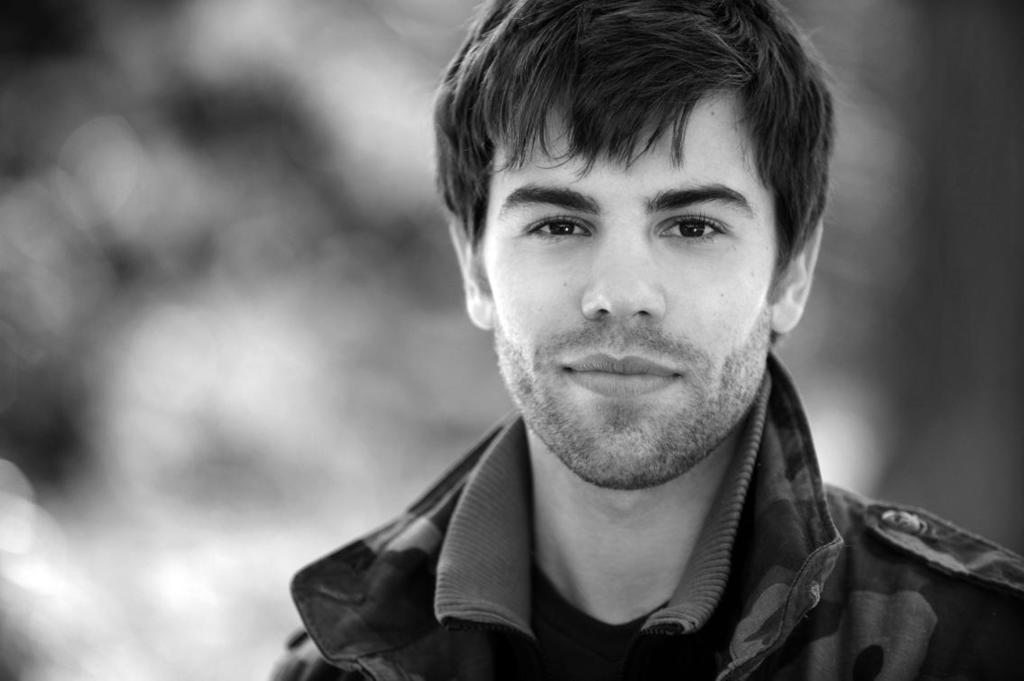What is the color scheme of the image? The image is black and white. Can you describe the main subject in the image? There is a person in the image. What is the appearance of the background in the image? The background of the image is blurred. What type of feather can be seen in the image? There is no feather present in the image. How does the person in the image demonstrate their power? The image does not show the person demonstrating any power or ability. 